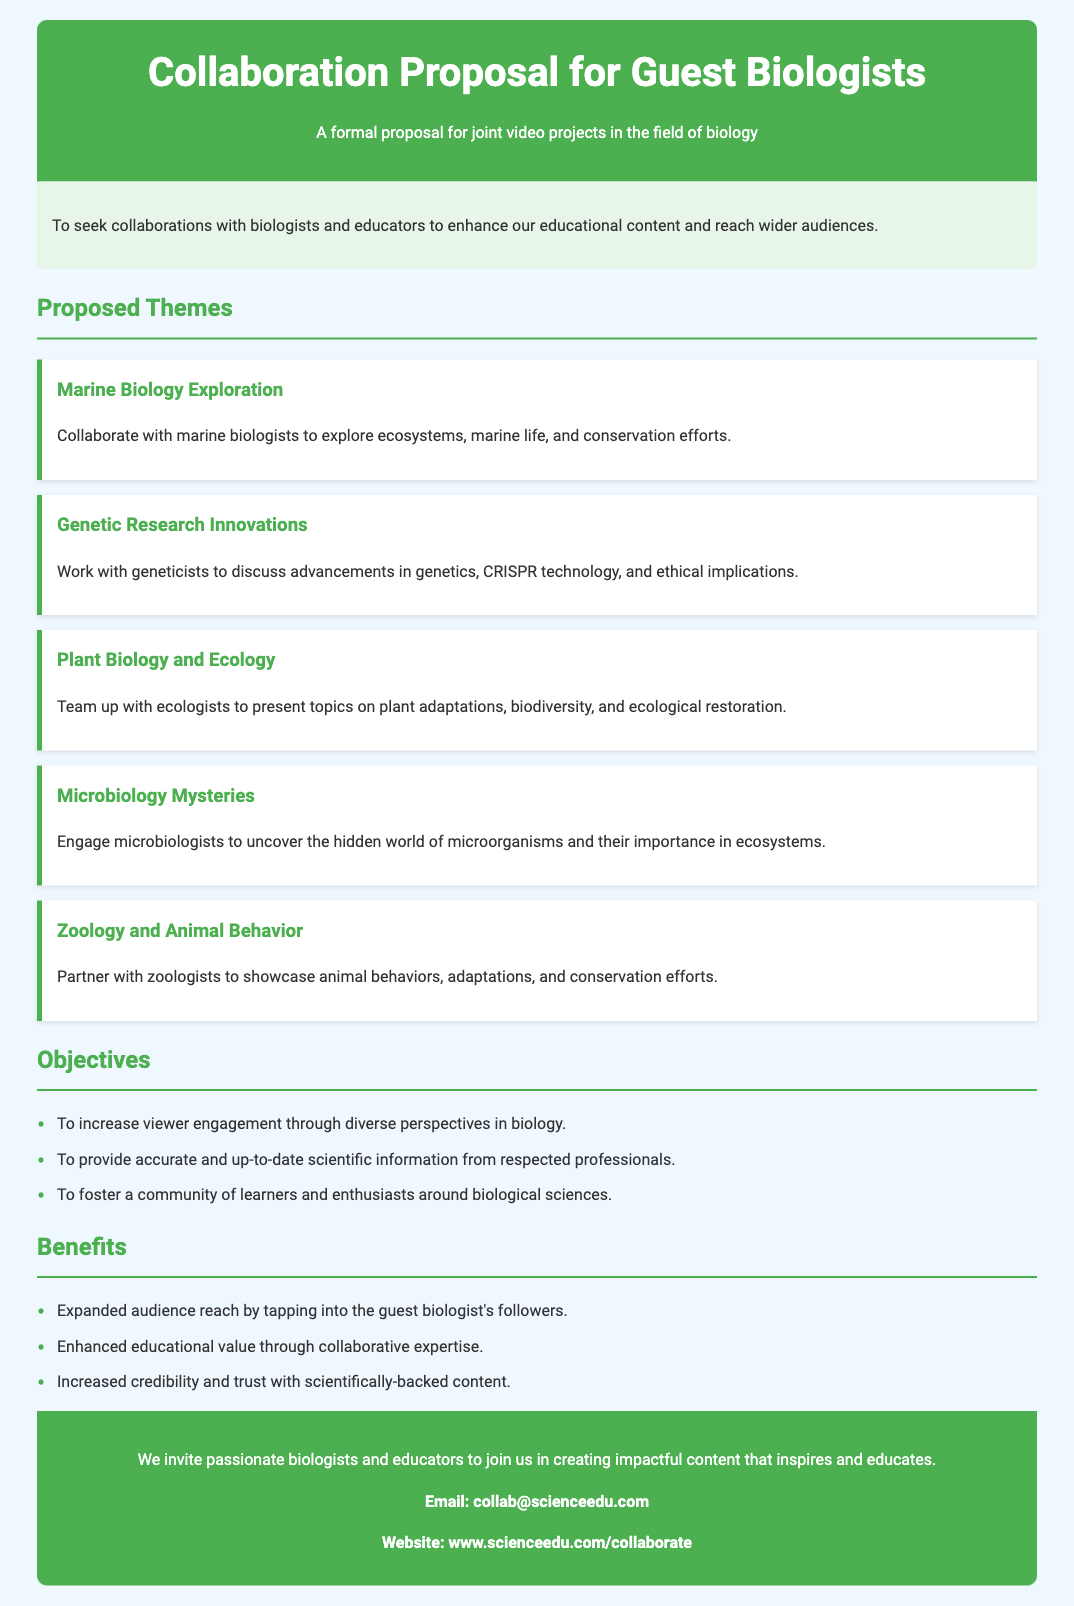what is the document title? The title of the document is present in the header section.
Answer: Collaboration Proposal for Guest Biologists what is the primary purpose of the proposal? The purpose of the proposal is stated in a dedicated section.
Answer: To seek collaborations with biologists and educators how many proposed themes are listed? The number of themes can be counted from the respective section in the document.
Answer: Five which theme focuses on animal behavior? The themes include titles that indicate their respective areas of focus.
Answer: Zoology and Animal Behavior name one objective of the collaboration proposal. Objectives are listed in a bullet point format.
Answer: To increase viewer engagement through diverse perspectives in biology what is one benefit of collaborating mentioned in the document? Benefits are listed as key advantages of collaboration in a bullet form.
Answer: Expanded audience reach by tapping into the guest biologist's followers who should interested parties contact for collaboration? Contact information is provided at the end of the document.
Answer: collab@scienceedu.com what background do the proposed guest biologists come from? The theme sections indicate the specific fields of expertise of potential collaborators.
Answer: Marine biology, genetics, ecology, microbiology, zoology what color is used for headings in the document? The color scheme is described in the style section for text elements.
Answer: Green 